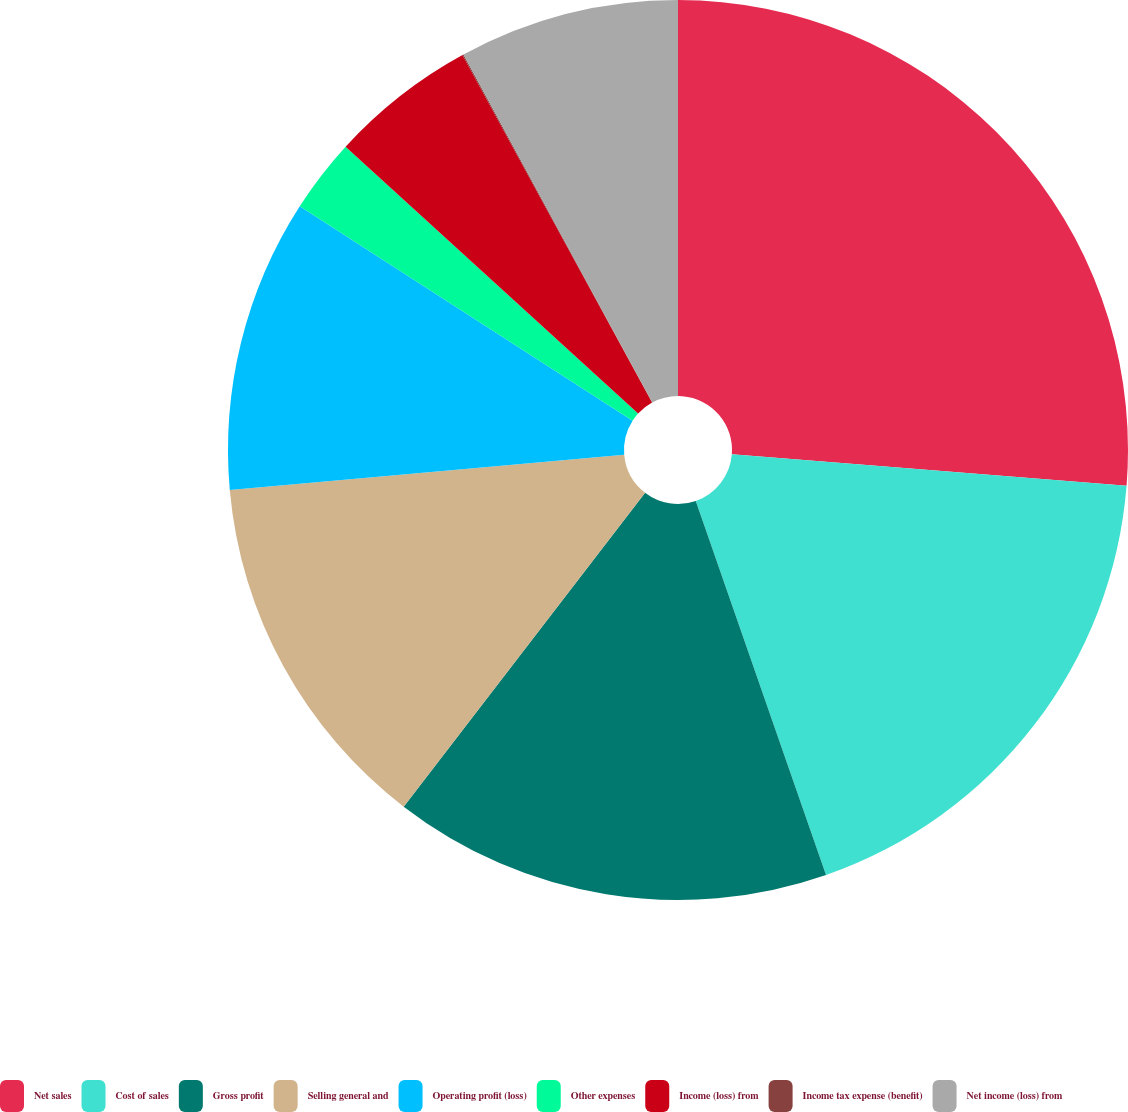Convert chart to OTSL. <chart><loc_0><loc_0><loc_500><loc_500><pie_chart><fcel>Net sales<fcel>Cost of sales<fcel>Gross profit<fcel>Selling general and<fcel>Operating profit (loss)<fcel>Other expenses<fcel>Income (loss) from<fcel>Income tax expense (benefit)<fcel>Net income (loss) from<nl><fcel>26.27%<fcel>18.4%<fcel>15.77%<fcel>13.15%<fcel>10.53%<fcel>2.66%<fcel>5.28%<fcel>0.04%<fcel>7.91%<nl></chart> 